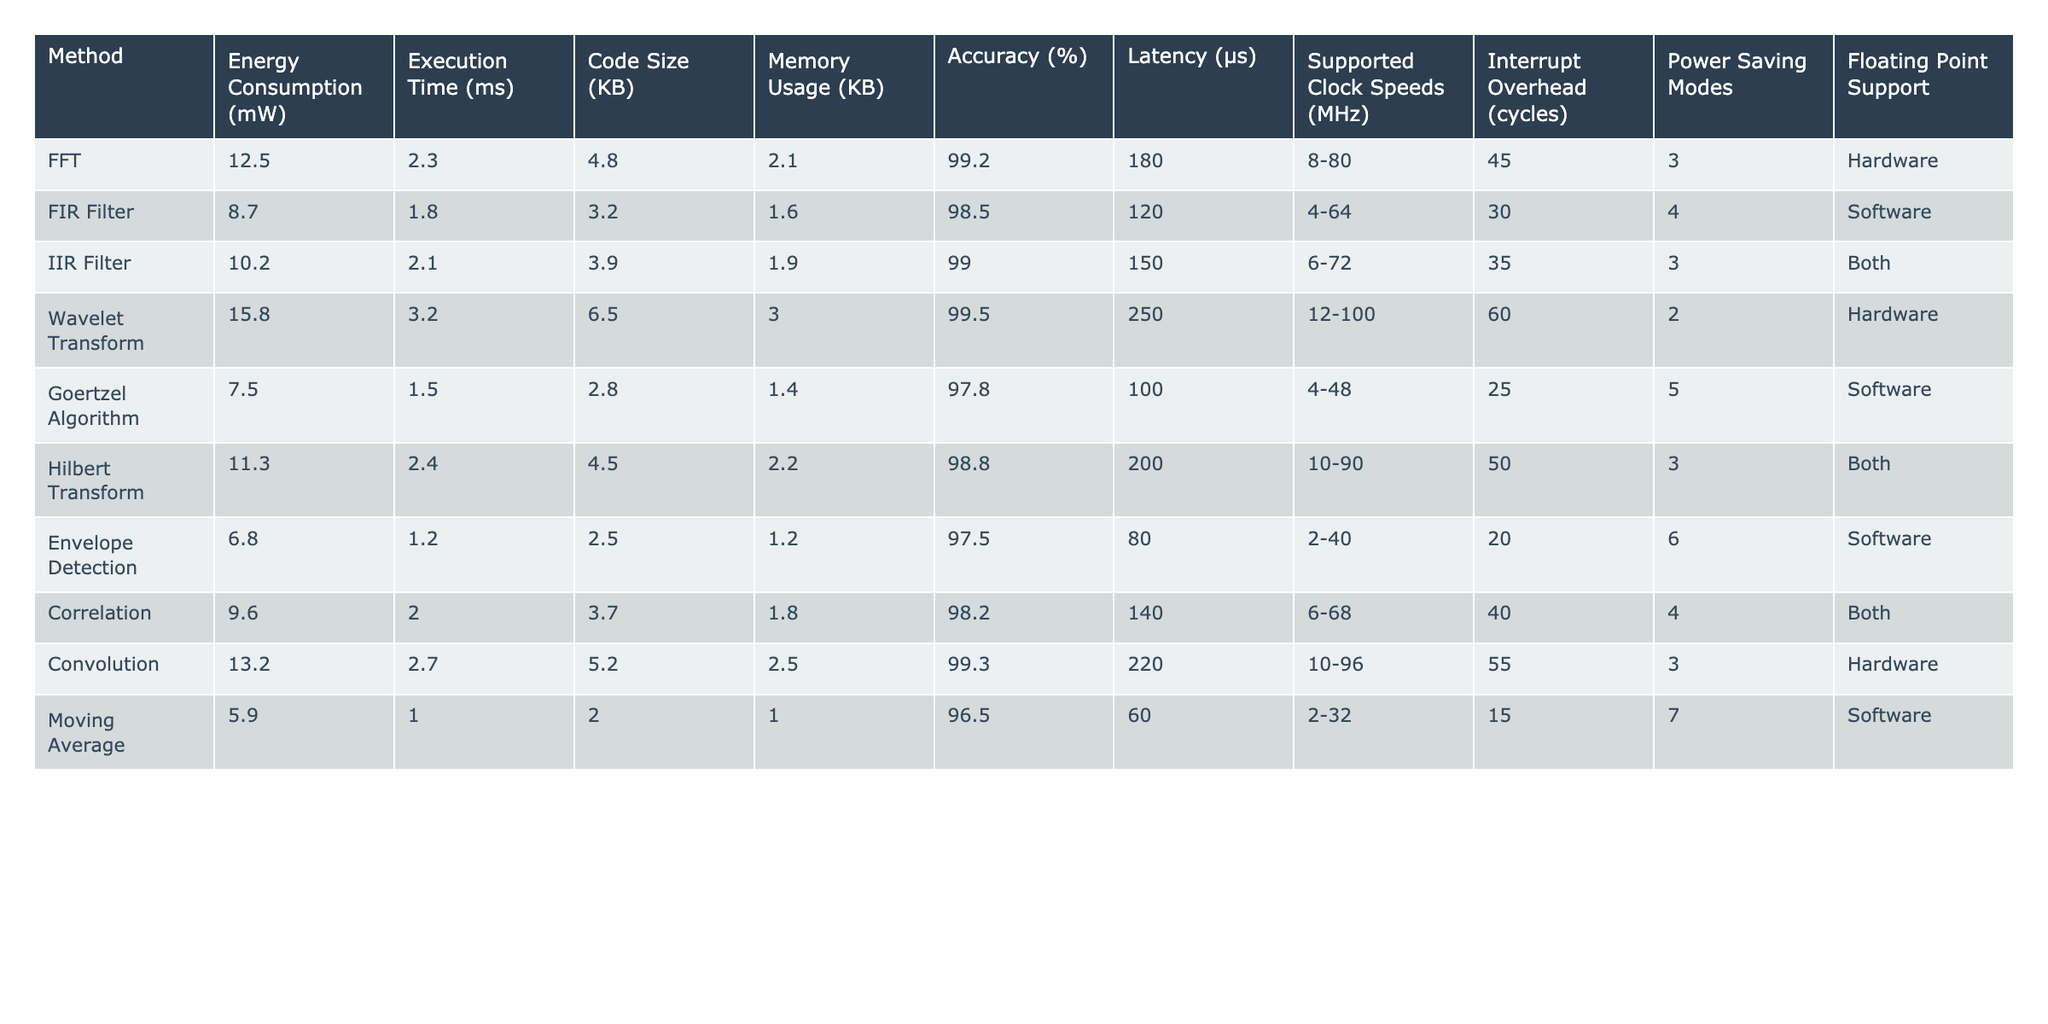What is the energy consumption of the FFT method? The table lists the energy consumption for the FFT method as 12.5 mW.
Answer: 12.5 mW Which method has the highest accuracy? By examining the accuracy column, the Wavelet Transform has the highest accuracy at 99.5%.
Answer: 99.5% What are the energy consumption values of all methods combined? To find the total energy consumption, sum all individual energy consumptions: 12.5 + 8.7 + 10.2 + 15.8 + 7.5 + 11.3 + 6.8 + 9.6 + 13.2 + 5.9 = 89.5 mW.
Answer: 89.5 mW Is the Goertzel Algorithm a hardware or software method? The table indicates that the Goertzel Algorithm is a software method.
Answer: Software Which method has the shortest execution time? The execution time for each method is compared, and the Moving Average method has the shortest execution time at 1.0 ms.
Answer: 1.0 ms How does the energy consumption of the IIR Filter compare to the FIR Filter? The IIR Filter consumes 10.2 mW, while the FIR Filter consumes 8.7 mW. Thus, the IIR Filter consumes more energy than the FIR Filter by 1.5 mW.
Answer: IIR Filter consumes 1.5 mW more What is the average memory usage of all the methods? To calculate the average, add the memory usage values and divide by the number of methods: (2.1 + 1.6 + 1.9 + 3.0 + 1.4 + 2.2 + 1.2 + 1.8 + 2.5 + 1.0) / 10 = 1.75 KB.
Answer: 1.75 KB Are there any methods that support floating point operations? Yes, there are methods that support floating point operations: FFT and IIR Filter support hardware, while the Hilbert Transform and Correlation support both, and Goertzel Algorithm supports software.
Answer: Yes Which method has the lowest latency and what is it? The latency values for each method are checked, and the Moving Average has the lowest latency of 60 µs.
Answer: 60 µs Which method is the most power-efficient based on energy consumption and accuracy? Power efficiency can be considered by comparing energy consumption relative to accuracy. The Envelope Detection method has the lowest energy consumption (6.8 mW) and an accuracy of 97.5%. However, it’s necessary to consider that the Wavelet Transform has higher accuracy (99.5%) despite higher energy consumption.
Answer: Envelope Detection What is the difference in execution time between the Wavelet Transform and the Moving Average? The execution time for Wavelet Transform is 3.2 ms, and for the Moving Average, it is 1.0 ms. The difference is 3.2 - 1.0 = 2.2 ms, meaning the Wavelet Transform takes longer.
Answer: 2.2 ms 